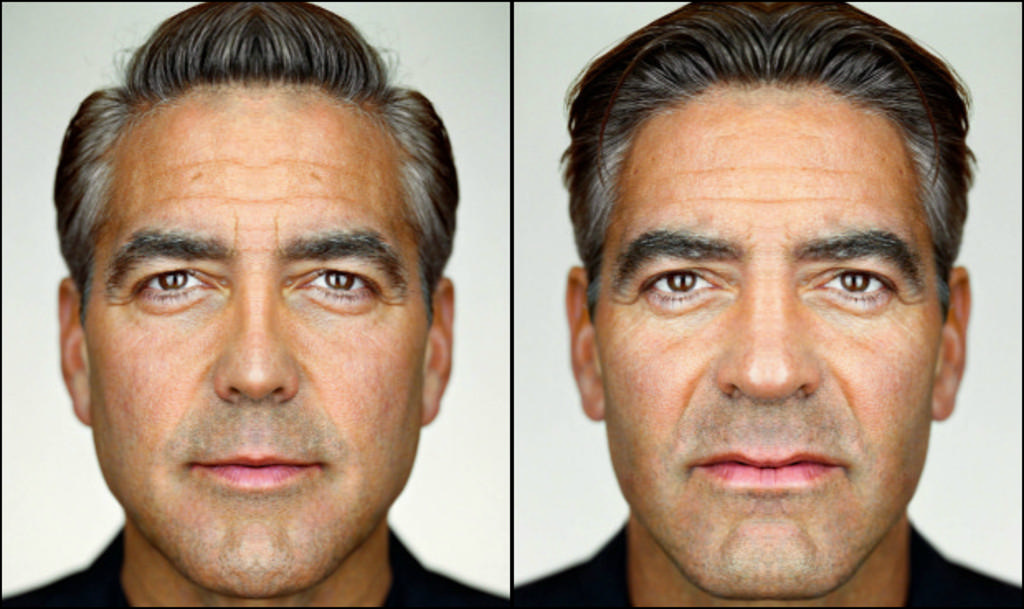What format is used for the images in the picture? The image is a photo grid. How many images of the man are present in the photo grid? There are two images of a man beside each other in the photo grid. What suggestion does the man make during the meeting in the image? There is no meeting depicted in the image, and therefore no suggestion can be observed. 